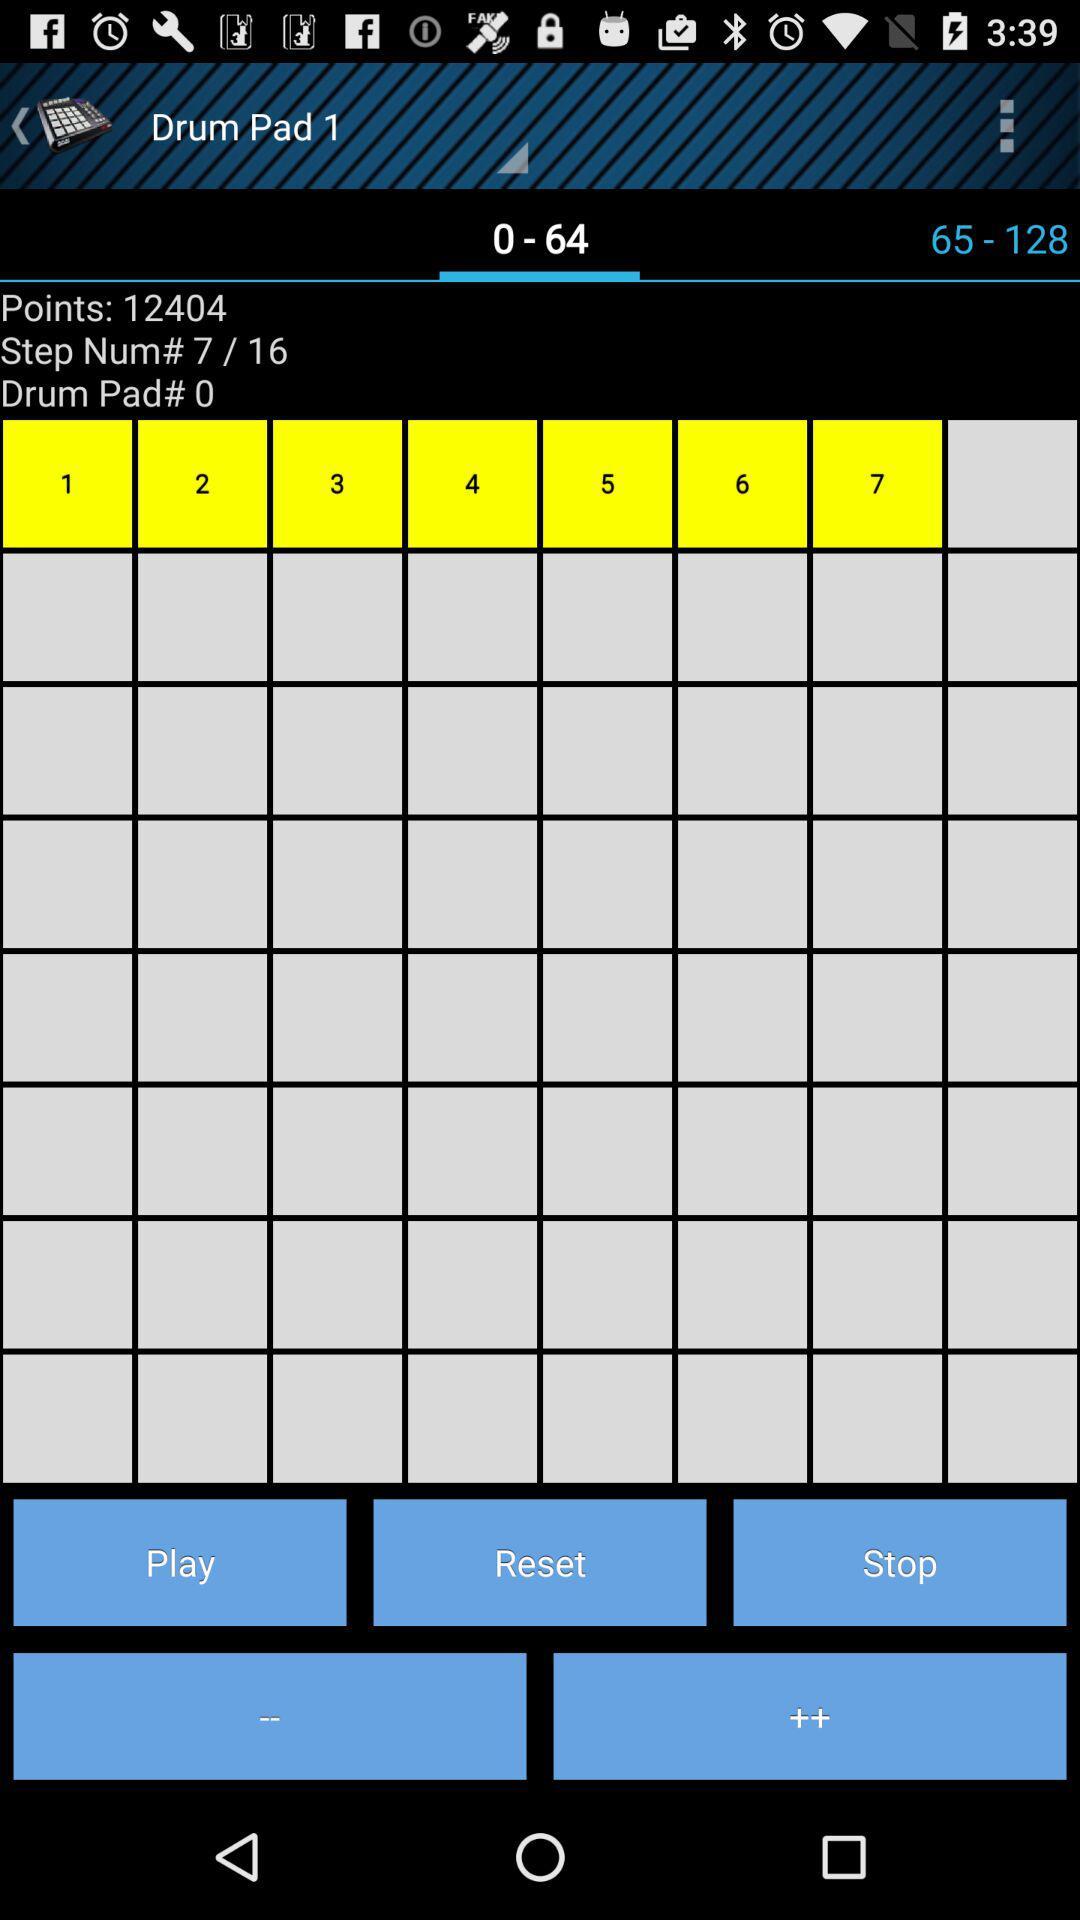Which option is selected in "Drum Pad 1"? The selected option is "0 - 64". 